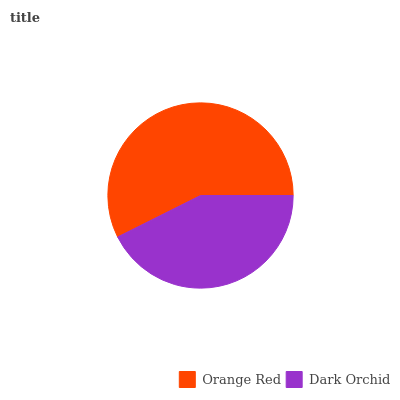Is Dark Orchid the minimum?
Answer yes or no. Yes. Is Orange Red the maximum?
Answer yes or no. Yes. Is Dark Orchid the maximum?
Answer yes or no. No. Is Orange Red greater than Dark Orchid?
Answer yes or no. Yes. Is Dark Orchid less than Orange Red?
Answer yes or no. Yes. Is Dark Orchid greater than Orange Red?
Answer yes or no. No. Is Orange Red less than Dark Orchid?
Answer yes or no. No. Is Orange Red the high median?
Answer yes or no. Yes. Is Dark Orchid the low median?
Answer yes or no. Yes. Is Dark Orchid the high median?
Answer yes or no. No. Is Orange Red the low median?
Answer yes or no. No. 